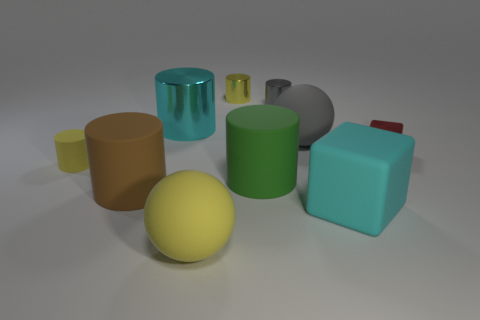Subtract all brown rubber cylinders. How many cylinders are left? 5 Subtract all gray balls. How many balls are left? 1 Subtract all yellow cubes. How many yellow cylinders are left? 2 Subtract 4 cylinders. How many cylinders are left? 2 Subtract all cylinders. How many objects are left? 4 Add 1 red objects. How many red objects are left? 2 Add 8 green matte things. How many green matte things exist? 9 Subtract 1 cyan cubes. How many objects are left? 9 Subtract all brown spheres. Subtract all cyan cylinders. How many spheres are left? 2 Subtract all small gray metal cylinders. Subtract all rubber things. How many objects are left? 3 